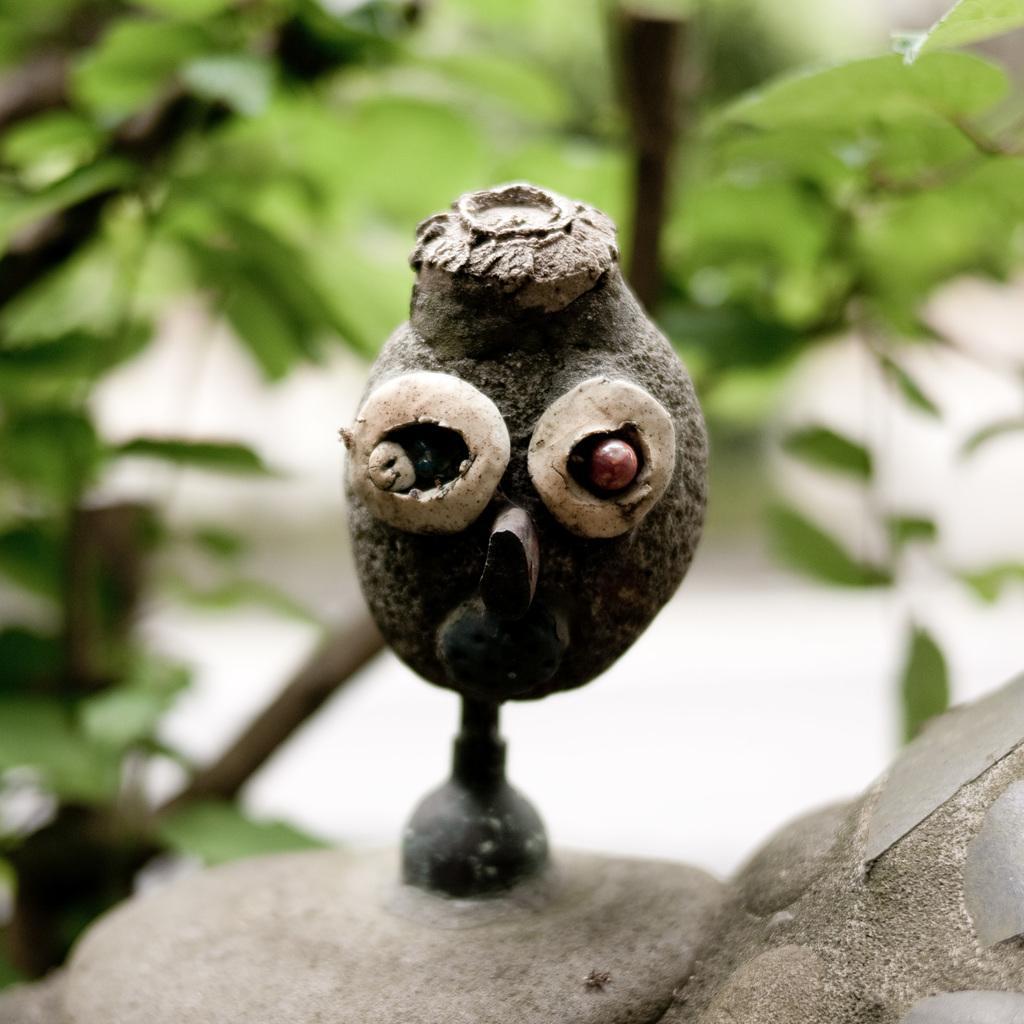How would you summarize this image in a sentence or two? In this image, we can see an object in the middle and we can see some green leaves. 